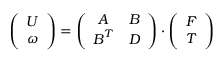<formula> <loc_0><loc_0><loc_500><loc_500>\left ( \begin{array} { c } { U } \\ { \omega } \end{array} \right ) = \left ( \begin{array} { c c } { A } & { B } \\ { B ^ { T } } & { D } \end{array} \right ) \cdot \left ( \begin{array} { c } { F } \\ { T } \end{array} \right )</formula> 